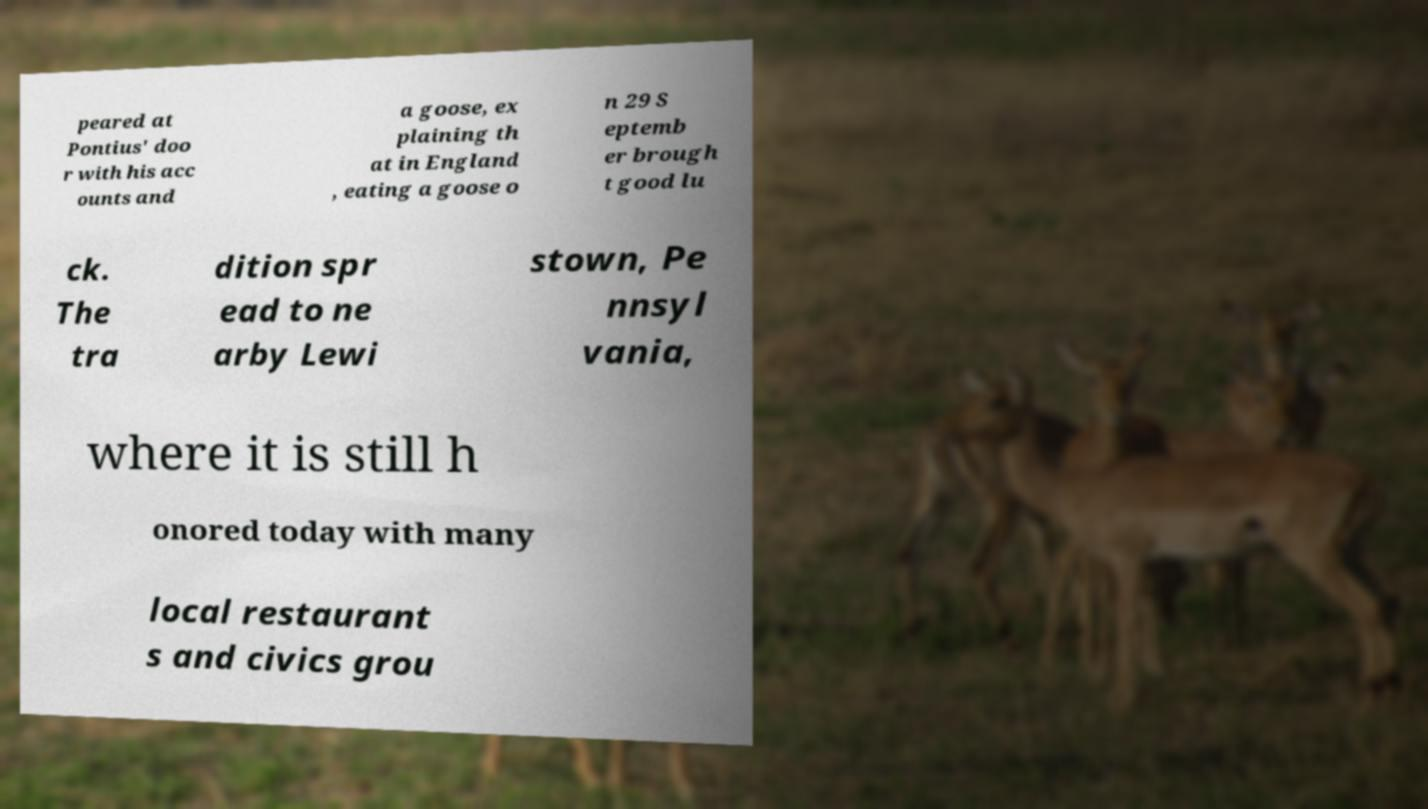Can you read and provide the text displayed in the image?This photo seems to have some interesting text. Can you extract and type it out for me? peared at Pontius' doo r with his acc ounts and a goose, ex plaining th at in England , eating a goose o n 29 S eptemb er brough t good lu ck. The tra dition spr ead to ne arby Lewi stown, Pe nnsyl vania, where it is still h onored today with many local restaurant s and civics grou 